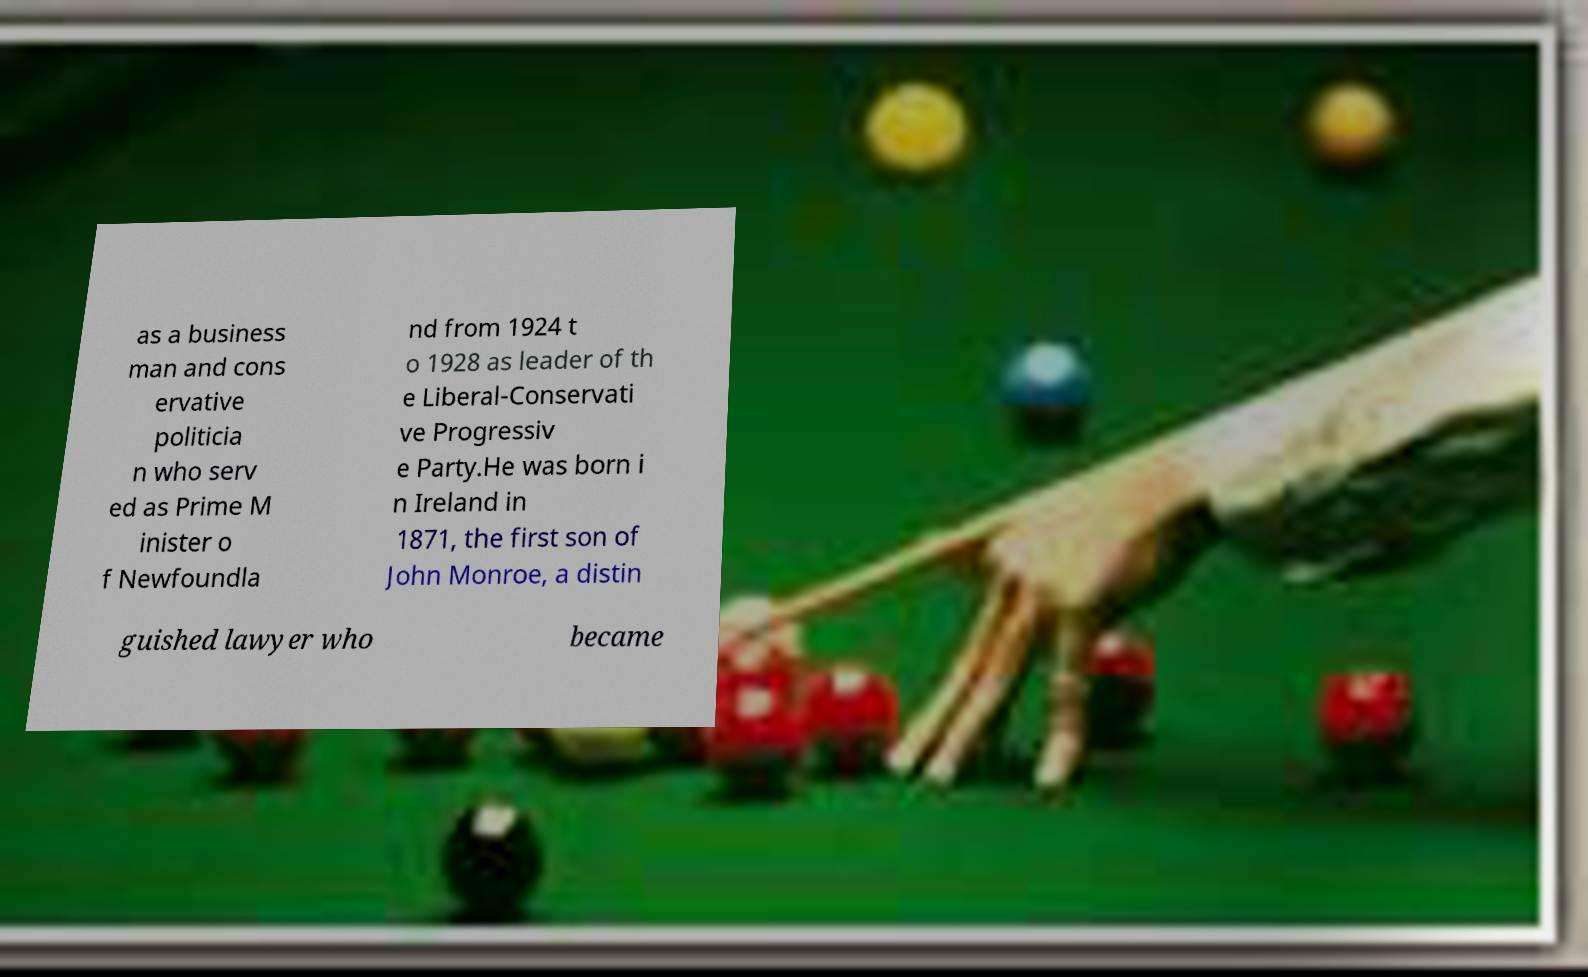What messages or text are displayed in this image? I need them in a readable, typed format. as a business man and cons ervative politicia n who serv ed as Prime M inister o f Newfoundla nd from 1924 t o 1928 as leader of th e Liberal-Conservati ve Progressiv e Party.He was born i n Ireland in 1871, the first son of John Monroe, a distin guished lawyer who became 